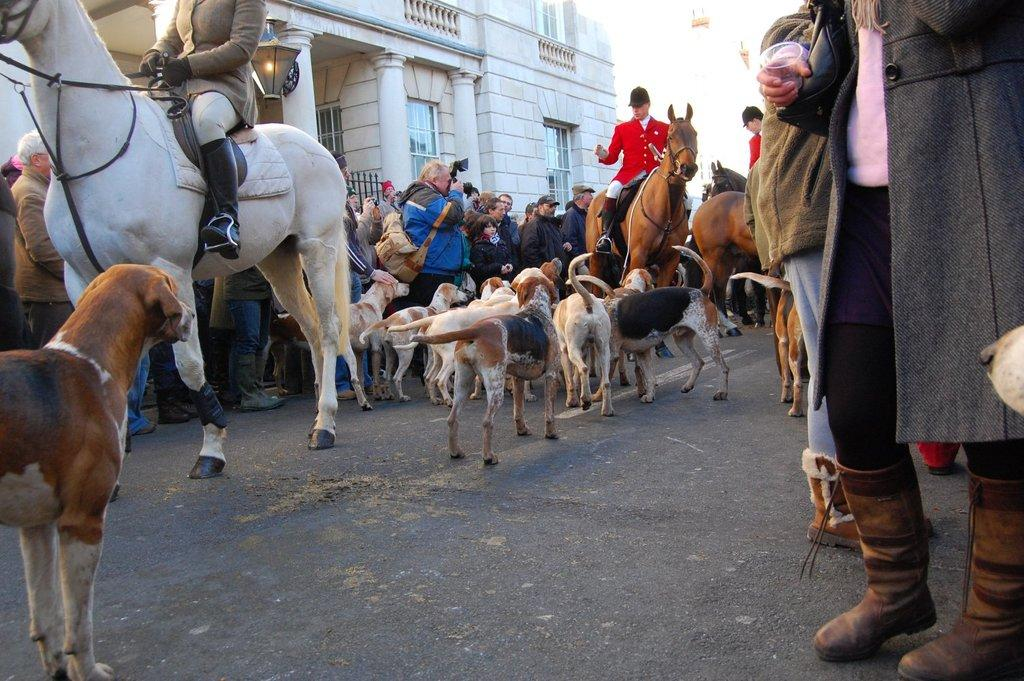What are the people doing in the image? There are people sitting on horses in the image. What other animals are present in the image? There are dogs in the image. What is happening on the road in the image? There are people on the road, and some of them are taking photos with cameras. What type of structure can be seen in the image? There is a building in the image. How does the island contribute to the scene in the image? There is no island present in the image; it features people sitting on horses, dogs, people on the road, and a building. 